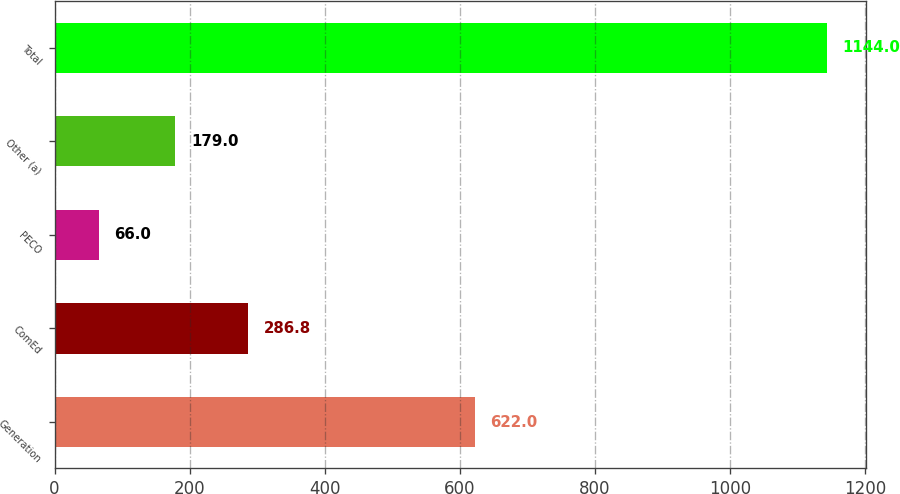<chart> <loc_0><loc_0><loc_500><loc_500><bar_chart><fcel>Generation<fcel>ComEd<fcel>PECO<fcel>Other (a)<fcel>Total<nl><fcel>622<fcel>286.8<fcel>66<fcel>179<fcel>1144<nl></chart> 